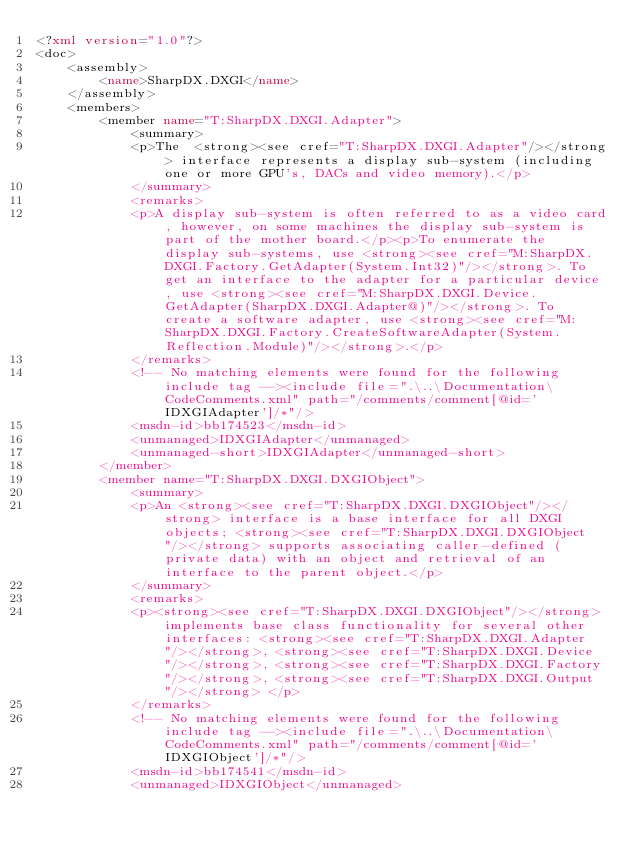Convert code to text. <code><loc_0><loc_0><loc_500><loc_500><_XML_><?xml version="1.0"?>
<doc>
    <assembly>
        <name>SharpDX.DXGI</name>
    </assembly>
    <members>
        <member name="T:SharpDX.DXGI.Adapter">
            <summary>	
            <p>The  <strong><see cref="T:SharpDX.DXGI.Adapter"/></strong> interface represents a display sub-system (including one or more GPU's, DACs and video memory).</p>	
            </summary>	
            <remarks>	
            <p>A display sub-system is often referred to as a video card, however, on some machines the display sub-system is part of the mother board.</p><p>To enumerate the display sub-systems, use <strong><see cref="M:SharpDX.DXGI.Factory.GetAdapter(System.Int32)"/></strong>. To get an interface to the adapter for a particular device, use <strong><see cref="M:SharpDX.DXGI.Device.GetAdapter(SharpDX.DXGI.Adapter@)"/></strong>. To create a software adapter, use <strong><see cref="M:SharpDX.DXGI.Factory.CreateSoftwareAdapter(System.Reflection.Module)"/></strong>.</p>	
            </remarks>	
            <!-- No matching elements were found for the following include tag --><include file=".\..\Documentation\CodeComments.xml" path="/comments/comment[@id='IDXGIAdapter']/*"/>	
            <msdn-id>bb174523</msdn-id>	
            <unmanaged>IDXGIAdapter</unmanaged>	
            <unmanaged-short>IDXGIAdapter</unmanaged-short>	
        </member>
        <member name="T:SharpDX.DXGI.DXGIObject">
            <summary>	
            <p>An <strong><see cref="T:SharpDX.DXGI.DXGIObject"/></strong> interface is a base interface for all DXGI objects; <strong><see cref="T:SharpDX.DXGI.DXGIObject"/></strong> supports associating caller-defined (private data) with an object and retrieval of an interface to the parent object.</p>	
            </summary>	
            <remarks>	
            <p><strong><see cref="T:SharpDX.DXGI.DXGIObject"/></strong> implements base class functionality for several other interfaces: <strong><see cref="T:SharpDX.DXGI.Adapter"/></strong>, <strong><see cref="T:SharpDX.DXGI.Device"/></strong>, <strong><see cref="T:SharpDX.DXGI.Factory"/></strong>, <strong><see cref="T:SharpDX.DXGI.Output"/></strong> </p>	
            </remarks>	
            <!-- No matching elements were found for the following include tag --><include file=".\..\Documentation\CodeComments.xml" path="/comments/comment[@id='IDXGIObject']/*"/>	
            <msdn-id>bb174541</msdn-id>	
            <unmanaged>IDXGIObject</unmanaged>	</code> 